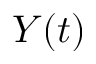<formula> <loc_0><loc_0><loc_500><loc_500>Y ( t )</formula> 